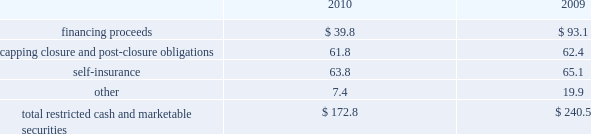At december 31 .
The table summarizes our restricted cash and marketable securities as of december .
We own a 19.9% ( 19.9 % ) interest in a company that , among other activities , issues financial surety bonds to secure capping , closure and post-closure obligations for companies operating in the solid waste industry .
We account for this investment under the cost method of accounting .
There have been no identified events or changes in circumstances that may have a significant adverse effect on the fair value of the investment .
This investee company and the parent company of the investee had written surety bonds for us relating to our landfill operations for capping , closure and post-closure , of which $ 855.0 million and $ 775.2 million were outstanding as of december 31 , 2010 and 2009 , respectively .
Our reimbursement obligations under these bonds are secured by an indemnity agreement with the investee and letters of credit totaling $ 45.0 million and $ 67.4 million as of december 31 , 2010 and 2009 , respectively .
Off-balance sheet arrangements we have no off-balance sheet debt or similar obligations , other than operating leases and the financial assurances discussed above , which are not classified as debt .
We have no transactions or obligations with related parties that are not disclosed , consolidated into or reflected in our reported financial position or results of operations .
We have not guaranteed any third-party debt .
Guarantees we enter into contracts in the normal course of business that include indemnification clauses .
Indemnifications relating to known liabilities are recorded in the consolidated financial statements based on our best estimate of required future payments .
Certain of these indemnifications relate to contingent events or occurrences , such as the imposition of additional taxes due to a change in the tax law or adverse interpretation of the tax law , and indemnifications made in divestiture agreements where we indemnify the buyer for liabilities that relate to our activities prior to the divestiture and that may become known in the future .
We do not believe that these contingent obligations will have a material effect on our consolidated financial position , results of operations or cash flows .
We have entered into agreements with property owners to guarantee the value of property that is adjacent to certain of our landfills .
These agreements have varying terms .
We do not believe that these contingent obligations will have a material effect on our consolidated financial position , results of operations or cash flows .
Other matters our business activities are conducted in the context of a developing and changing statutory and regulatory framework .
Governmental regulation of the waste management industry requires us to obtain and retain numerous governmental permits to conduct various aspects of our operations .
These permits are subject to revocation , modification or denial .
The costs and other capital expenditures which may be required to obtain or retain the applicable permits or comply with applicable regulations could be significant .
Any revocation , modification or denial of permits could have a material adverse effect on us .
Republic services , inc .
Notes to consolidated financial statements , continued .
In 2010 what was the percent of the financing proceeds as part of the total restricted cash and marketable securities? 
Computations: (39.8 / 172.8)
Answer: 0.23032. 